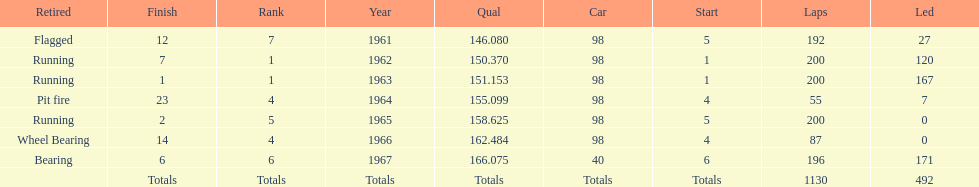How many times did he finish in the top three? 2. 